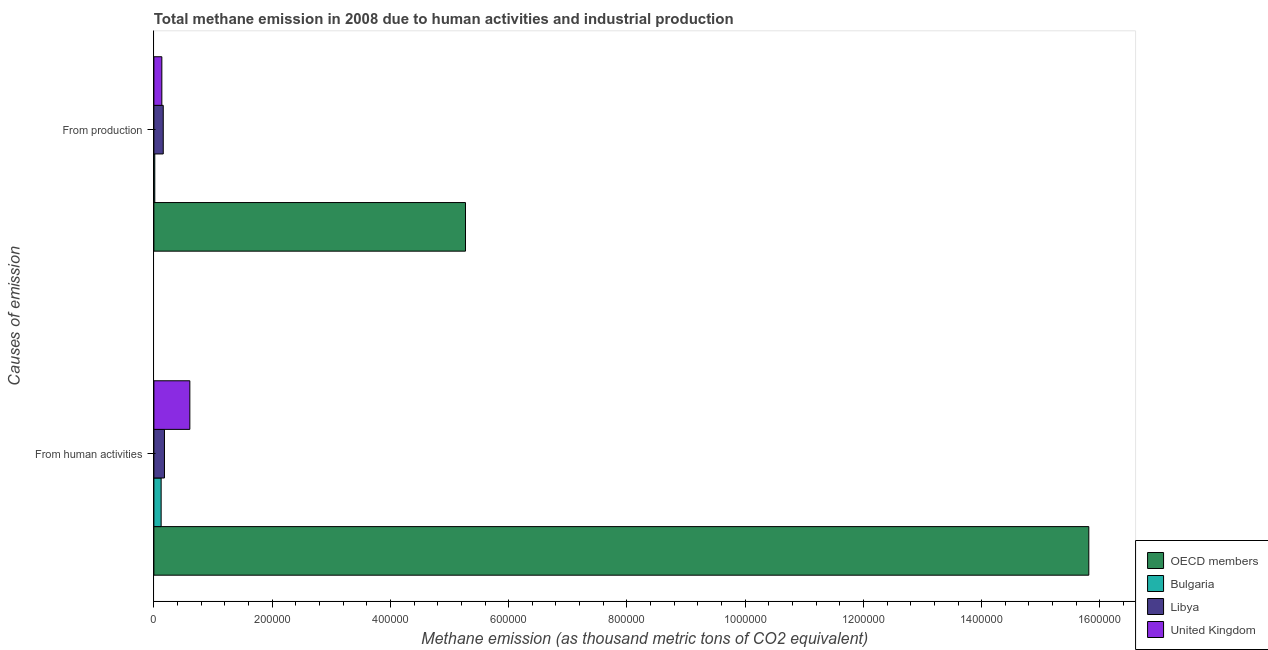How many different coloured bars are there?
Offer a terse response. 4. How many bars are there on the 2nd tick from the top?
Provide a succinct answer. 4. How many bars are there on the 2nd tick from the bottom?
Your answer should be very brief. 4. What is the label of the 1st group of bars from the top?
Provide a succinct answer. From production. What is the amount of emissions from human activities in Bulgaria?
Offer a terse response. 1.23e+04. Across all countries, what is the maximum amount of emissions from human activities?
Ensure brevity in your answer.  1.58e+06. Across all countries, what is the minimum amount of emissions from human activities?
Provide a succinct answer. 1.23e+04. What is the total amount of emissions generated from industries in the graph?
Give a very brief answer. 5.58e+05. What is the difference between the amount of emissions from human activities in Bulgaria and that in Libya?
Ensure brevity in your answer.  -5609.8. What is the difference between the amount of emissions from human activities in Bulgaria and the amount of emissions generated from industries in United Kingdom?
Provide a short and direct response. -1188.8. What is the average amount of emissions from human activities per country?
Offer a very short reply. 4.18e+05. What is the difference between the amount of emissions from human activities and amount of emissions generated from industries in OECD members?
Offer a very short reply. 1.05e+06. What is the ratio of the amount of emissions from human activities in OECD members to that in Libya?
Ensure brevity in your answer.  88.38. In how many countries, is the amount of emissions from human activities greater than the average amount of emissions from human activities taken over all countries?
Give a very brief answer. 1. What does the 3rd bar from the bottom in From human activities represents?
Your answer should be very brief. Libya. Are all the bars in the graph horizontal?
Provide a succinct answer. Yes. How many countries are there in the graph?
Provide a succinct answer. 4. Are the values on the major ticks of X-axis written in scientific E-notation?
Provide a succinct answer. No. How many legend labels are there?
Keep it short and to the point. 4. How are the legend labels stacked?
Give a very brief answer. Vertical. What is the title of the graph?
Your response must be concise. Total methane emission in 2008 due to human activities and industrial production. Does "Solomon Islands" appear as one of the legend labels in the graph?
Provide a short and direct response. No. What is the label or title of the X-axis?
Provide a short and direct response. Methane emission (as thousand metric tons of CO2 equivalent). What is the label or title of the Y-axis?
Provide a short and direct response. Causes of emission. What is the Methane emission (as thousand metric tons of CO2 equivalent) in OECD members in From human activities?
Make the answer very short. 1.58e+06. What is the Methane emission (as thousand metric tons of CO2 equivalent) of Bulgaria in From human activities?
Give a very brief answer. 1.23e+04. What is the Methane emission (as thousand metric tons of CO2 equivalent) of Libya in From human activities?
Your answer should be compact. 1.79e+04. What is the Methane emission (as thousand metric tons of CO2 equivalent) of United Kingdom in From human activities?
Provide a succinct answer. 6.08e+04. What is the Methane emission (as thousand metric tons of CO2 equivalent) in OECD members in From production?
Keep it short and to the point. 5.27e+05. What is the Methane emission (as thousand metric tons of CO2 equivalent) in Bulgaria in From production?
Your answer should be very brief. 1528. What is the Methane emission (as thousand metric tons of CO2 equivalent) in Libya in From production?
Your response must be concise. 1.58e+04. What is the Methane emission (as thousand metric tons of CO2 equivalent) of United Kingdom in From production?
Offer a very short reply. 1.35e+04. Across all Causes of emission, what is the maximum Methane emission (as thousand metric tons of CO2 equivalent) of OECD members?
Your response must be concise. 1.58e+06. Across all Causes of emission, what is the maximum Methane emission (as thousand metric tons of CO2 equivalent) of Bulgaria?
Provide a short and direct response. 1.23e+04. Across all Causes of emission, what is the maximum Methane emission (as thousand metric tons of CO2 equivalent) in Libya?
Make the answer very short. 1.79e+04. Across all Causes of emission, what is the maximum Methane emission (as thousand metric tons of CO2 equivalent) of United Kingdom?
Keep it short and to the point. 6.08e+04. Across all Causes of emission, what is the minimum Methane emission (as thousand metric tons of CO2 equivalent) in OECD members?
Provide a succinct answer. 5.27e+05. Across all Causes of emission, what is the minimum Methane emission (as thousand metric tons of CO2 equivalent) of Bulgaria?
Your response must be concise. 1528. Across all Causes of emission, what is the minimum Methane emission (as thousand metric tons of CO2 equivalent) of Libya?
Your answer should be compact. 1.58e+04. Across all Causes of emission, what is the minimum Methane emission (as thousand metric tons of CO2 equivalent) of United Kingdom?
Provide a short and direct response. 1.35e+04. What is the total Methane emission (as thousand metric tons of CO2 equivalent) of OECD members in the graph?
Ensure brevity in your answer.  2.11e+06. What is the total Methane emission (as thousand metric tons of CO2 equivalent) of Bulgaria in the graph?
Offer a terse response. 1.38e+04. What is the total Methane emission (as thousand metric tons of CO2 equivalent) of Libya in the graph?
Provide a succinct answer. 3.37e+04. What is the total Methane emission (as thousand metric tons of CO2 equivalent) in United Kingdom in the graph?
Keep it short and to the point. 7.43e+04. What is the difference between the Methane emission (as thousand metric tons of CO2 equivalent) of OECD members in From human activities and that in From production?
Keep it short and to the point. 1.05e+06. What is the difference between the Methane emission (as thousand metric tons of CO2 equivalent) in Bulgaria in From human activities and that in From production?
Your answer should be very brief. 1.08e+04. What is the difference between the Methane emission (as thousand metric tons of CO2 equivalent) in Libya in From human activities and that in From production?
Ensure brevity in your answer.  2043.5. What is the difference between the Methane emission (as thousand metric tons of CO2 equivalent) of United Kingdom in From human activities and that in From production?
Your answer should be compact. 4.73e+04. What is the difference between the Methane emission (as thousand metric tons of CO2 equivalent) of OECD members in From human activities and the Methane emission (as thousand metric tons of CO2 equivalent) of Bulgaria in From production?
Make the answer very short. 1.58e+06. What is the difference between the Methane emission (as thousand metric tons of CO2 equivalent) in OECD members in From human activities and the Methane emission (as thousand metric tons of CO2 equivalent) in Libya in From production?
Offer a very short reply. 1.57e+06. What is the difference between the Methane emission (as thousand metric tons of CO2 equivalent) in OECD members in From human activities and the Methane emission (as thousand metric tons of CO2 equivalent) in United Kingdom in From production?
Your answer should be very brief. 1.57e+06. What is the difference between the Methane emission (as thousand metric tons of CO2 equivalent) of Bulgaria in From human activities and the Methane emission (as thousand metric tons of CO2 equivalent) of Libya in From production?
Your answer should be compact. -3566.3. What is the difference between the Methane emission (as thousand metric tons of CO2 equivalent) in Bulgaria in From human activities and the Methane emission (as thousand metric tons of CO2 equivalent) in United Kingdom in From production?
Provide a succinct answer. -1188.8. What is the difference between the Methane emission (as thousand metric tons of CO2 equivalent) in Libya in From human activities and the Methane emission (as thousand metric tons of CO2 equivalent) in United Kingdom in From production?
Keep it short and to the point. 4421. What is the average Methane emission (as thousand metric tons of CO2 equivalent) in OECD members per Causes of emission?
Offer a very short reply. 1.05e+06. What is the average Methane emission (as thousand metric tons of CO2 equivalent) of Bulgaria per Causes of emission?
Provide a short and direct response. 6904.1. What is the average Methane emission (as thousand metric tons of CO2 equivalent) of Libya per Causes of emission?
Make the answer very short. 1.69e+04. What is the average Methane emission (as thousand metric tons of CO2 equivalent) in United Kingdom per Causes of emission?
Provide a succinct answer. 3.71e+04. What is the difference between the Methane emission (as thousand metric tons of CO2 equivalent) of OECD members and Methane emission (as thousand metric tons of CO2 equivalent) of Bulgaria in From human activities?
Give a very brief answer. 1.57e+06. What is the difference between the Methane emission (as thousand metric tons of CO2 equivalent) of OECD members and Methane emission (as thousand metric tons of CO2 equivalent) of Libya in From human activities?
Offer a very short reply. 1.56e+06. What is the difference between the Methane emission (as thousand metric tons of CO2 equivalent) in OECD members and Methane emission (as thousand metric tons of CO2 equivalent) in United Kingdom in From human activities?
Make the answer very short. 1.52e+06. What is the difference between the Methane emission (as thousand metric tons of CO2 equivalent) in Bulgaria and Methane emission (as thousand metric tons of CO2 equivalent) in Libya in From human activities?
Provide a succinct answer. -5609.8. What is the difference between the Methane emission (as thousand metric tons of CO2 equivalent) of Bulgaria and Methane emission (as thousand metric tons of CO2 equivalent) of United Kingdom in From human activities?
Keep it short and to the point. -4.85e+04. What is the difference between the Methane emission (as thousand metric tons of CO2 equivalent) in Libya and Methane emission (as thousand metric tons of CO2 equivalent) in United Kingdom in From human activities?
Ensure brevity in your answer.  -4.29e+04. What is the difference between the Methane emission (as thousand metric tons of CO2 equivalent) of OECD members and Methane emission (as thousand metric tons of CO2 equivalent) of Bulgaria in From production?
Offer a terse response. 5.25e+05. What is the difference between the Methane emission (as thousand metric tons of CO2 equivalent) in OECD members and Methane emission (as thousand metric tons of CO2 equivalent) in Libya in From production?
Give a very brief answer. 5.11e+05. What is the difference between the Methane emission (as thousand metric tons of CO2 equivalent) of OECD members and Methane emission (as thousand metric tons of CO2 equivalent) of United Kingdom in From production?
Give a very brief answer. 5.14e+05. What is the difference between the Methane emission (as thousand metric tons of CO2 equivalent) of Bulgaria and Methane emission (as thousand metric tons of CO2 equivalent) of Libya in From production?
Provide a short and direct response. -1.43e+04. What is the difference between the Methane emission (as thousand metric tons of CO2 equivalent) in Bulgaria and Methane emission (as thousand metric tons of CO2 equivalent) in United Kingdom in From production?
Give a very brief answer. -1.19e+04. What is the difference between the Methane emission (as thousand metric tons of CO2 equivalent) in Libya and Methane emission (as thousand metric tons of CO2 equivalent) in United Kingdom in From production?
Give a very brief answer. 2377.5. What is the ratio of the Methane emission (as thousand metric tons of CO2 equivalent) of OECD members in From human activities to that in From production?
Offer a terse response. 3. What is the ratio of the Methane emission (as thousand metric tons of CO2 equivalent) in Bulgaria in From human activities to that in From production?
Provide a succinct answer. 8.04. What is the ratio of the Methane emission (as thousand metric tons of CO2 equivalent) of Libya in From human activities to that in From production?
Your answer should be very brief. 1.13. What is the ratio of the Methane emission (as thousand metric tons of CO2 equivalent) of United Kingdom in From human activities to that in From production?
Your response must be concise. 4.52. What is the difference between the highest and the second highest Methane emission (as thousand metric tons of CO2 equivalent) of OECD members?
Ensure brevity in your answer.  1.05e+06. What is the difference between the highest and the second highest Methane emission (as thousand metric tons of CO2 equivalent) in Bulgaria?
Make the answer very short. 1.08e+04. What is the difference between the highest and the second highest Methane emission (as thousand metric tons of CO2 equivalent) of Libya?
Make the answer very short. 2043.5. What is the difference between the highest and the second highest Methane emission (as thousand metric tons of CO2 equivalent) in United Kingdom?
Give a very brief answer. 4.73e+04. What is the difference between the highest and the lowest Methane emission (as thousand metric tons of CO2 equivalent) of OECD members?
Your response must be concise. 1.05e+06. What is the difference between the highest and the lowest Methane emission (as thousand metric tons of CO2 equivalent) of Bulgaria?
Give a very brief answer. 1.08e+04. What is the difference between the highest and the lowest Methane emission (as thousand metric tons of CO2 equivalent) in Libya?
Provide a short and direct response. 2043.5. What is the difference between the highest and the lowest Methane emission (as thousand metric tons of CO2 equivalent) in United Kingdom?
Your answer should be compact. 4.73e+04. 